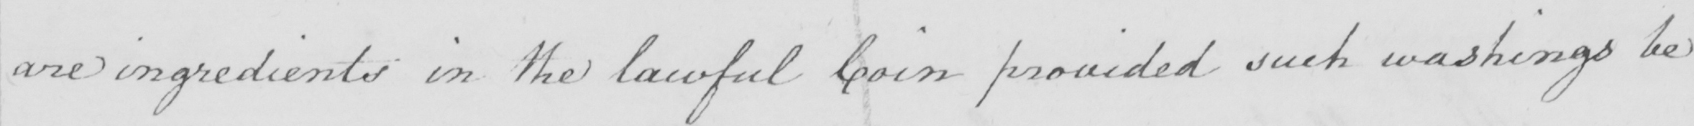Please transcribe the handwritten text in this image. are ingredients in the lawful Coin provided such washing be 